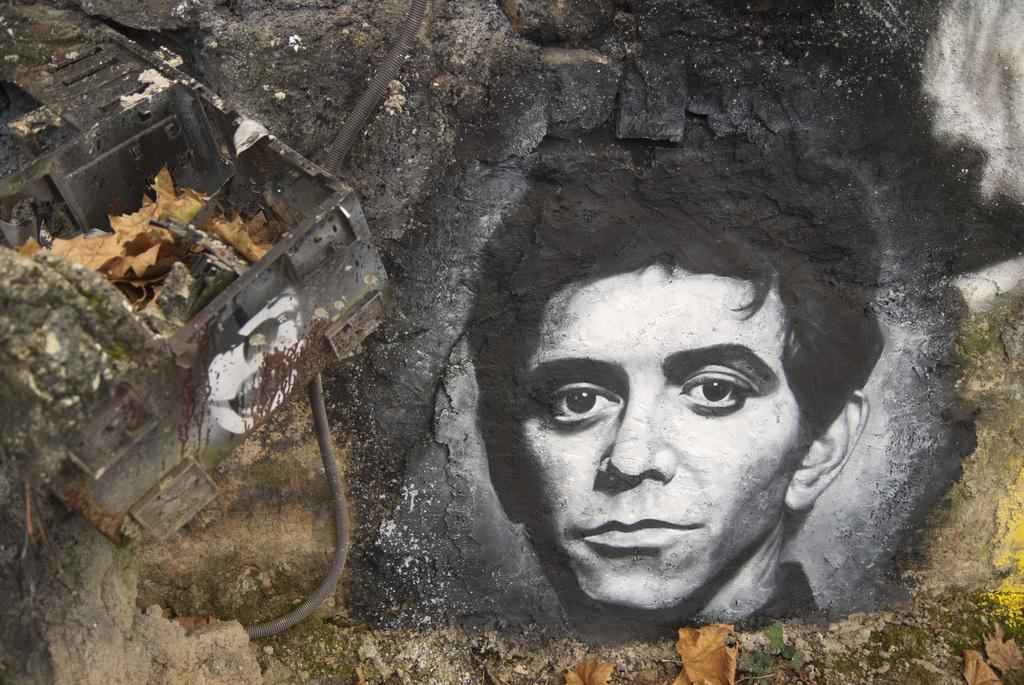What is depicted on the rock in the image? There is a painting of a person's face on a rock in the image. What object is located on the left side of the image? There is a box on the left side of the image. What is inside the box? There are dried leaves in the box. What type of club is associated with the person's face on the rock? There is no club associated with the person's face on the rock in the image. What religious symbol can be seen on the person's face in the painting? There is no religious symbol present on the person's face in the painting. 